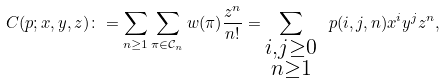<formula> <loc_0><loc_0><loc_500><loc_500>C ( p ; x , y , z ) \colon = \sum _ { n \geq 1 } \sum _ { \pi \in \mathcal { C } _ { n } } w ( \pi ) \frac { z ^ { n } } { n ! } = \sum _ { \substack { i , j \geq 0 \\ n \geq 1 } } \ p ( i , j , n ) x ^ { i } y ^ { j } z ^ { n } ,</formula> 